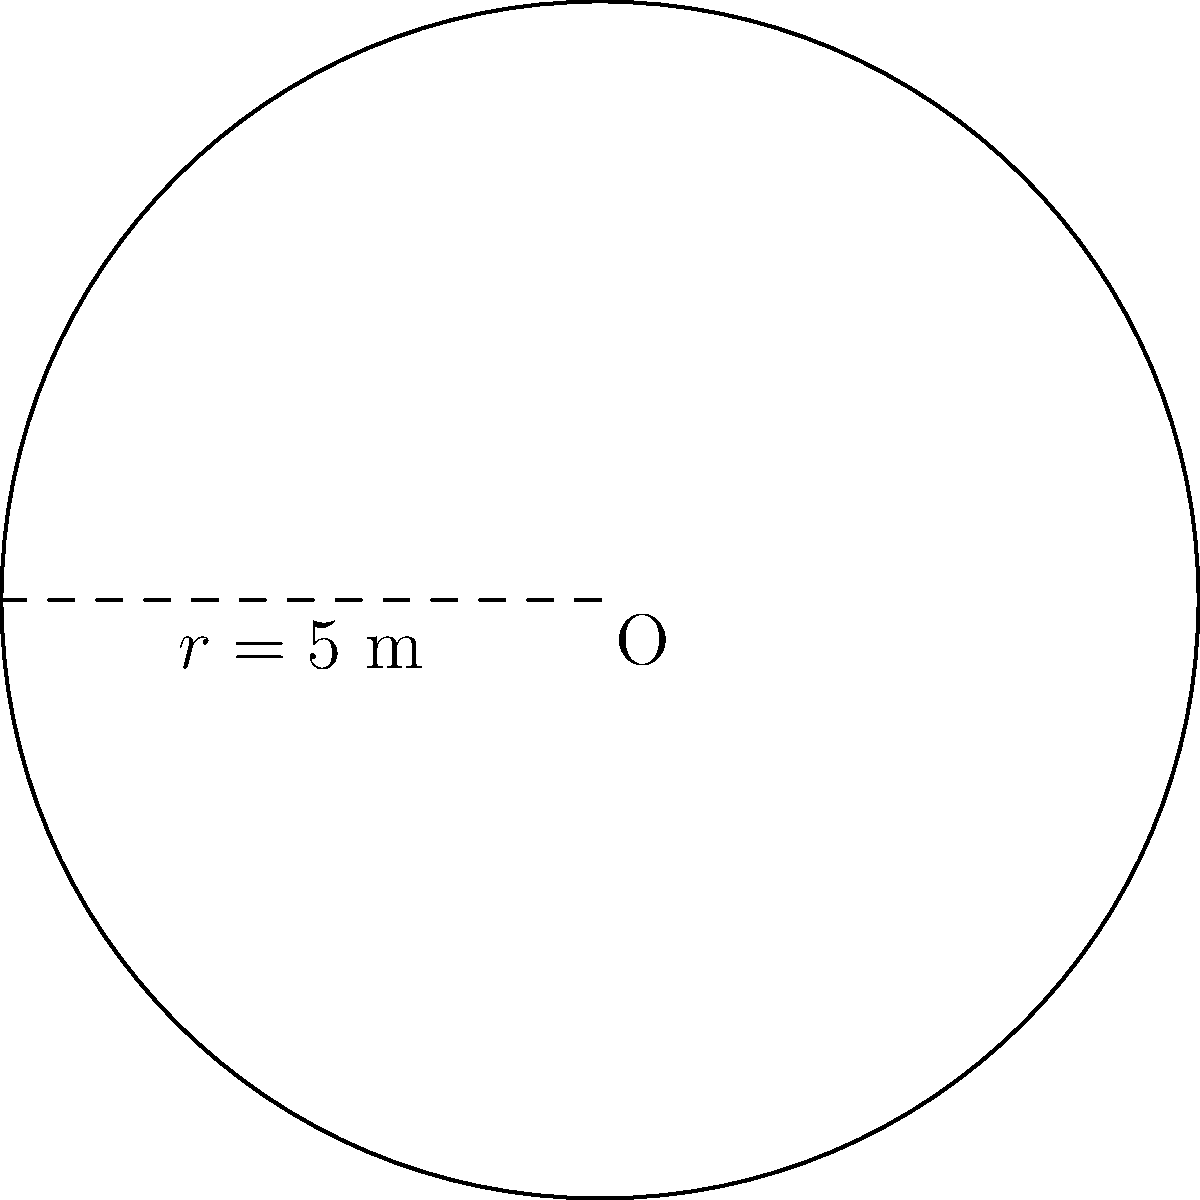In your beautiful circular garden, you've planted a variety of colorful flowers that bring joy to your daily walks. If the radius of your garden is 5 meters, what is the total area of this lovely floral haven? (Use $\pi \approx 3.14$) Let's calculate the area of your circular garden step by step:

1) The formula for the area of a circle is:
   $$A = \pi r^2$$
   Where $A$ is the area and $r$ is the radius.

2) We're given that the radius is 5 meters and we'll use $\pi \approx 3.14$.

3) Let's substitute these values into our formula:
   $$A = 3.14 \times 5^2$$

4) First, let's calculate $5^2$:
   $$A = 3.14 \times 25$$

5) Now, let's multiply:
   $$A = 78.5$$

6) The units will be square meters (m²).

Therefore, the area of your beautiful circular garden is approximately 78.5 square meters.
Answer: $78.5$ m² 